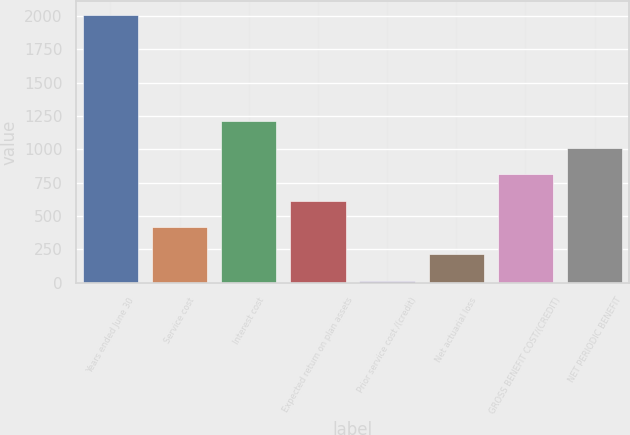<chart> <loc_0><loc_0><loc_500><loc_500><bar_chart><fcel>Years ended June 30<fcel>Service cost<fcel>Interest cost<fcel>Expected return on plan assets<fcel>Prior service cost /(credit)<fcel>Net actuarial loss<fcel>GROSS BENEFIT COST/(CREDIT)<fcel>NET PERIODIC BENEFIT<nl><fcel>2010<fcel>414<fcel>1212<fcel>613.5<fcel>15<fcel>214.5<fcel>813<fcel>1012.5<nl></chart> 